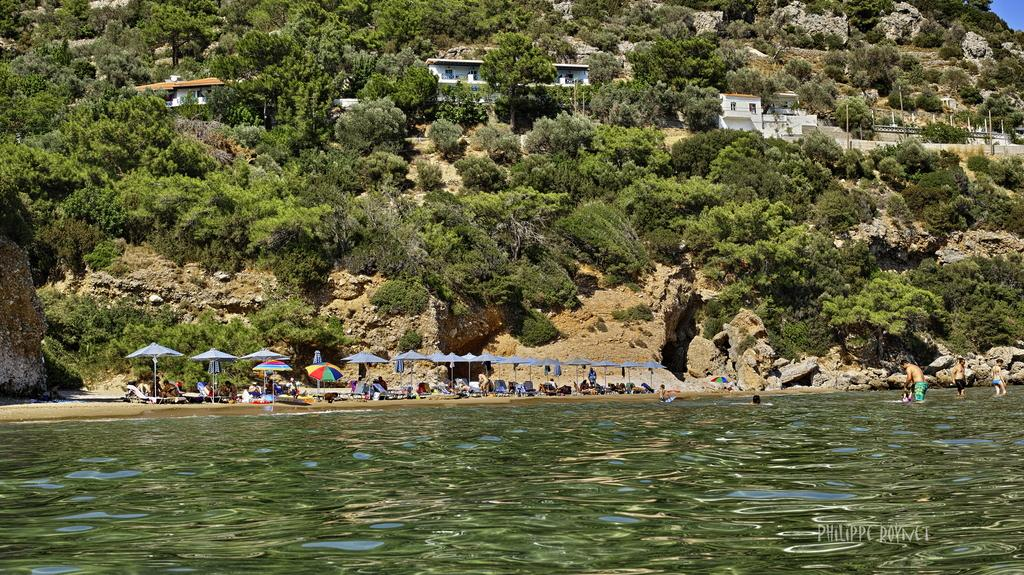What is at the bottom of the image? There is water at the bottom of the image. What are the people in the image doing? The people are in the water. What objects are providing shade in the image? There are parasols visible in the image. Who is using the parasols in the image? There are people associated with the parasols. What can be seen in the background of the image? There are trees and sheds in the background of the image. What type of toothpaste is being used by the people in the water? There is no toothpaste present in the image; it features people in water with parasols and background elements. How many cars can be seen in the image? There are no cars visible in the image. 